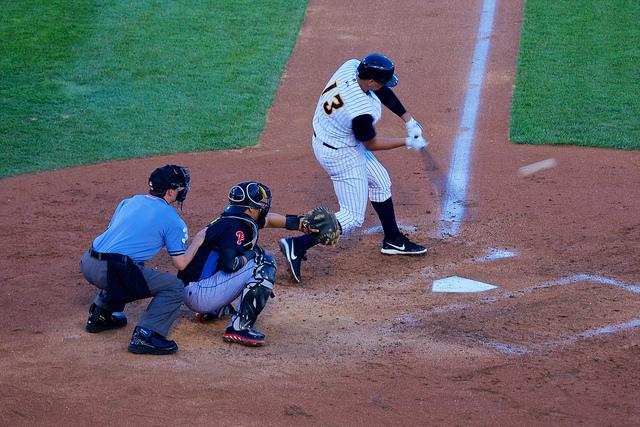What are the guys doing?
Give a very brief answer. Playing baseball. Is the catcher going to catch the ball?
Answer briefly. No. If he hits it where is he going to run to?
Give a very brief answer. First base. Is he going to hit the ball?
Give a very brief answer. Yes. 